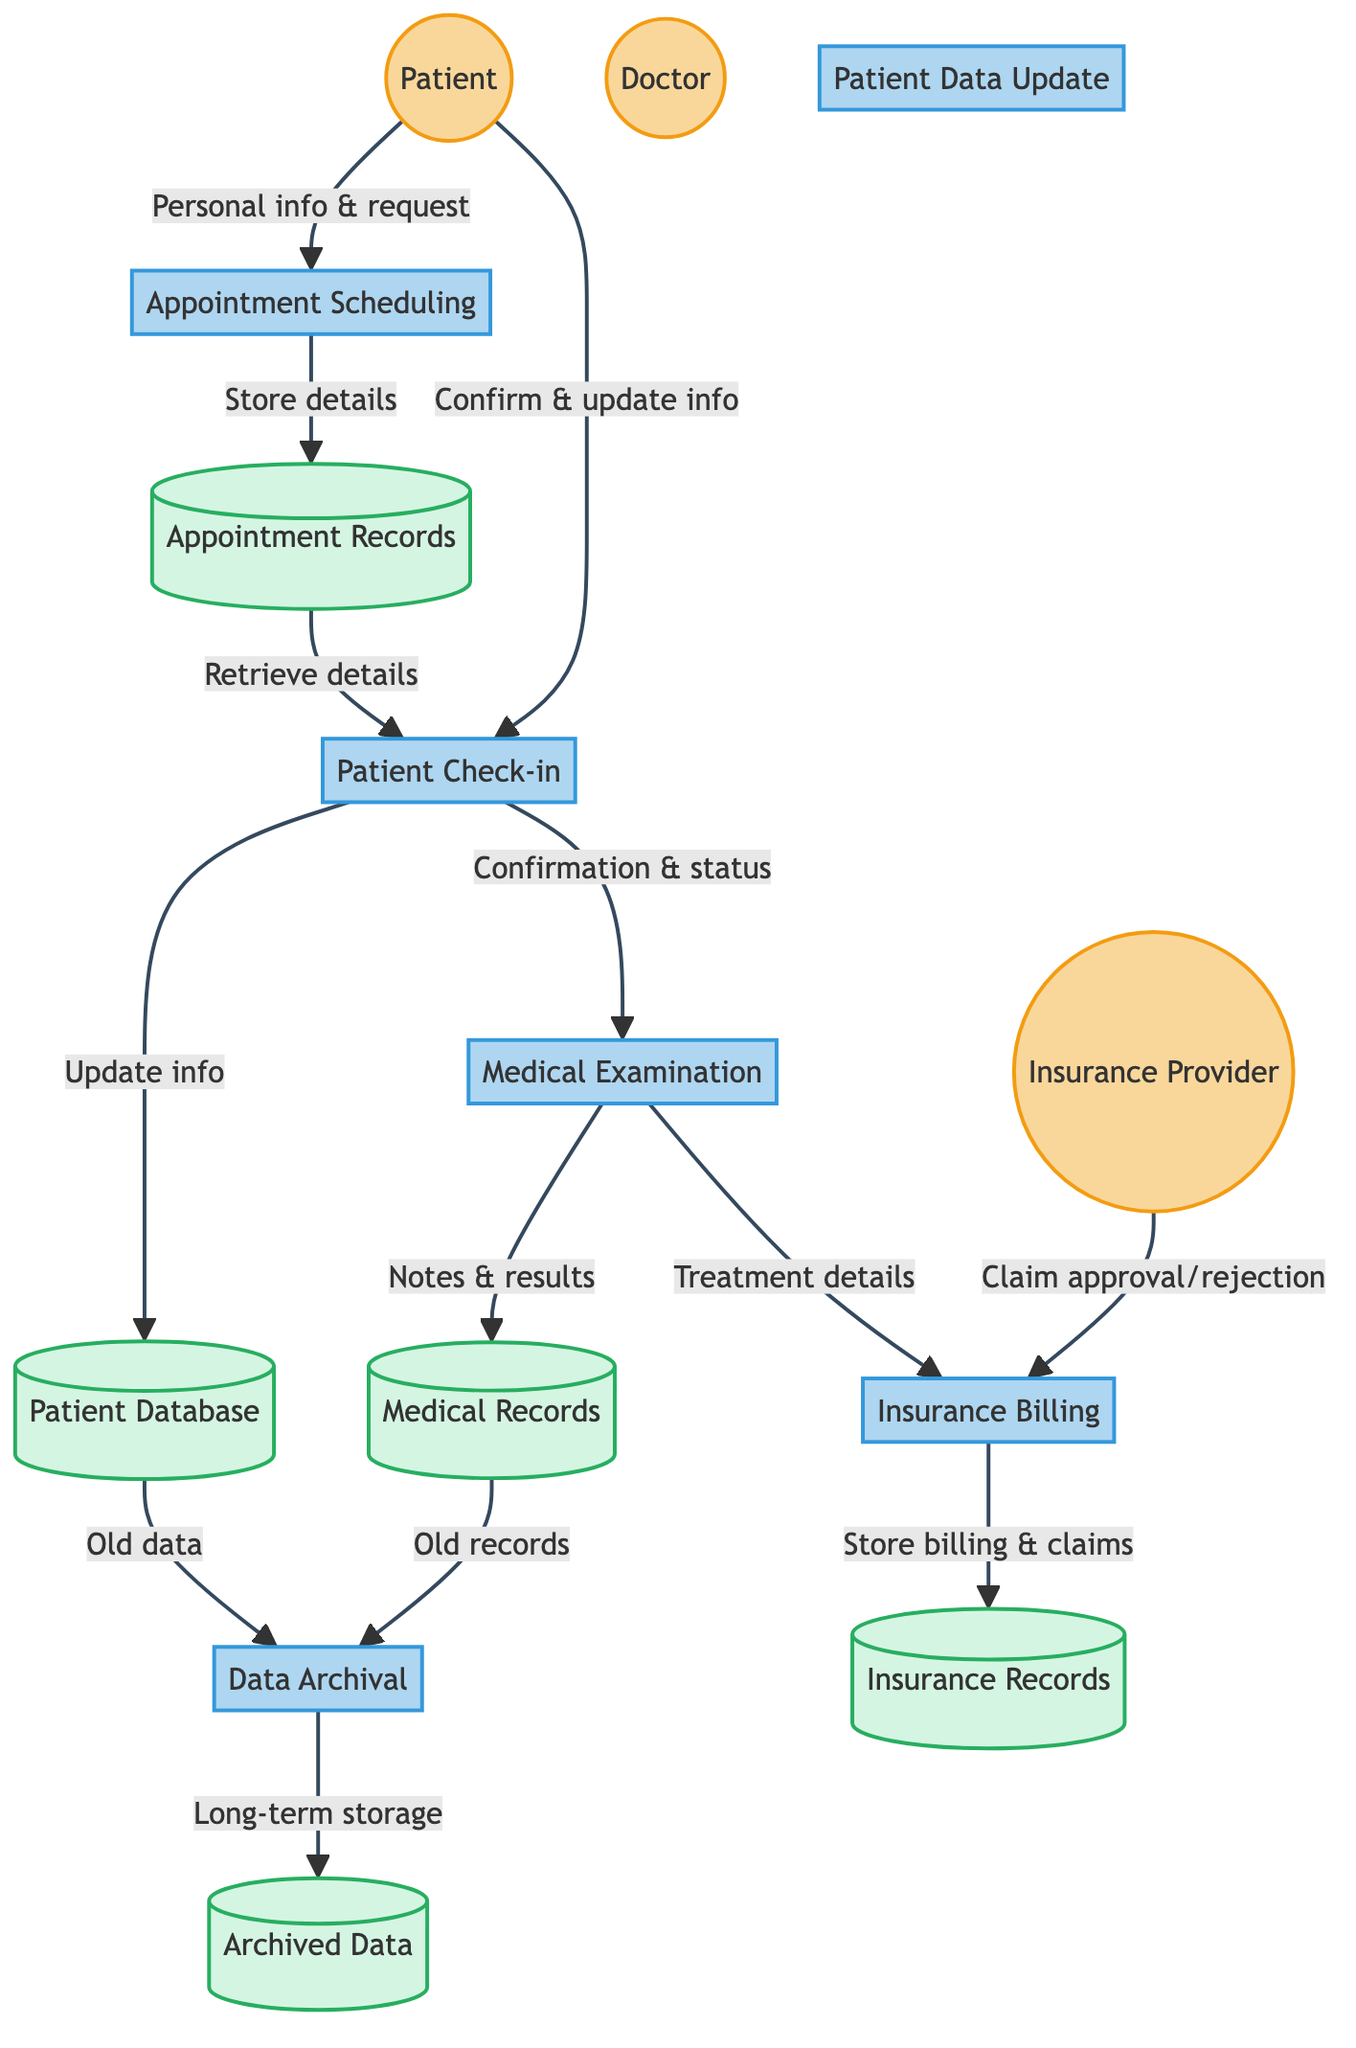What is the first process in the diagram? The diagram starts with the "Appointment Scheduling" process, which is the first step after the patient provides information.
Answer: Appointment Scheduling How many external entities are there? There are three external entities listed in the diagram, namely "Patient," "Doctor," and "Insurance Provider."
Answer: 3 Which process follows "Patient Check-in"? The process that follows "Patient Check-in" is "Medical Examination," indicating that the patient proceeds to see the doctor after checking in.
Answer: Medical Examination What type of data does the "Patient Database" store? The "Patient Database" is responsible for storing patients' personal and medical information. This indicates it holds essential data required for patient management.
Answer: Personal and medical information What is sent to "Insurance Billing" after "Medical Examination"? After "Medical Examination," the treatment details are sent to "Insurance Billing" for processing claims.
Answer: Treatment details How is the connection between "Patient" and "Medical Examination" established? The connection is established through the "Patient Check-in," which sends a confirmation and patient status to the "Medical Examination" process, showing that the patient has confirmed attendance.
Answer: Confirmation and status How many processes are there in total? The diagram contains six processes describing the various functions from appointment scheduling to data archival in patient management.
Answer: 6 What does "Data Archival" do with old patient data? "Data Archival" transfers old patient data for long-term storage, ensuring that historical records are preserved securely.
Answer: Long-term storage Which process retrieves scheduled appointment details? "Patient Check-in" retrieves scheduled appointment details from "Appointment Records" to confirm the patient's attendance during their visit.
Answer: Patient Check-in What type of information does "Insurance Billing" store? "Insurance Billing" stores billing and claims information after processing treatment details and receiving approval or rejection from the insurance provider.
Answer: Billing and claims information 